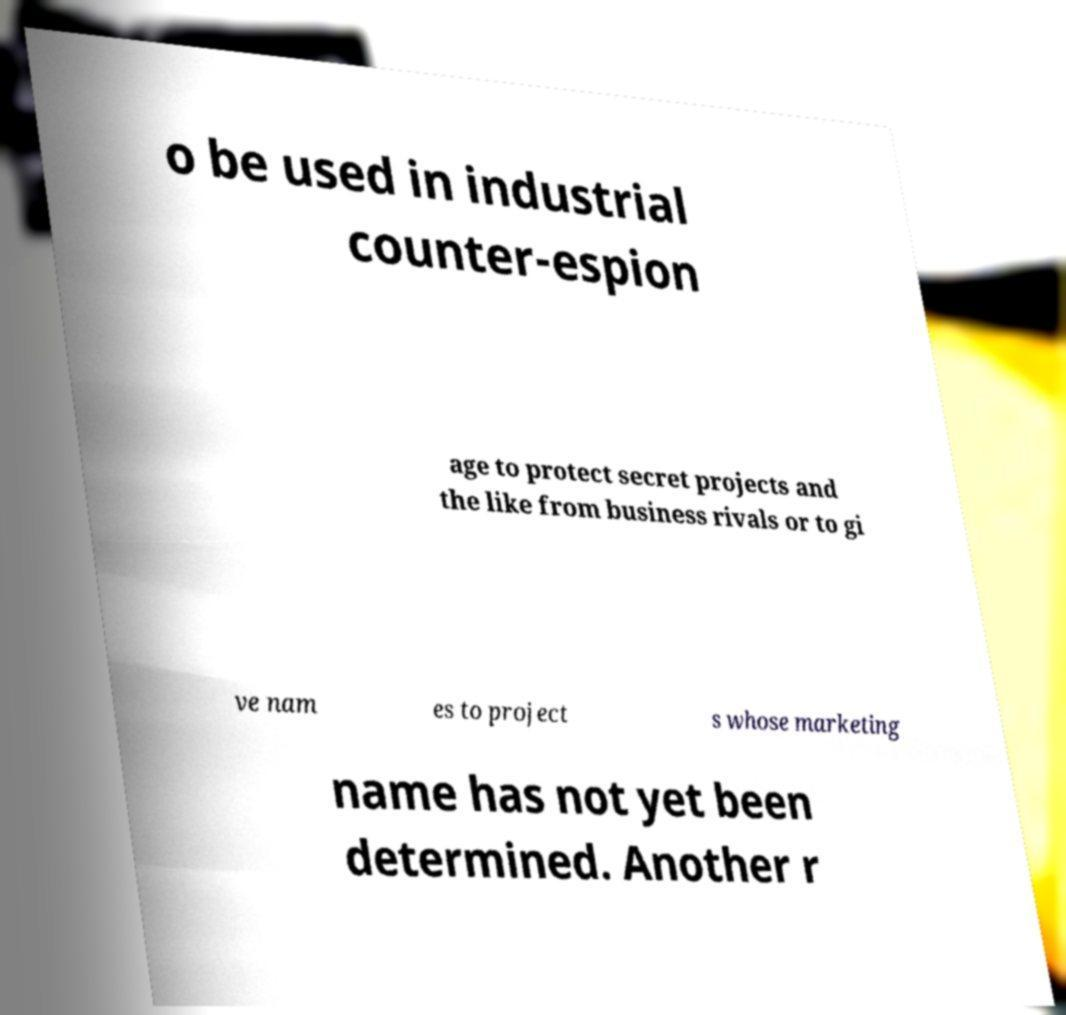Please read and relay the text visible in this image. What does it say? o be used in industrial counter-espion age to protect secret projects and the like from business rivals or to gi ve nam es to project s whose marketing name has not yet been determined. Another r 